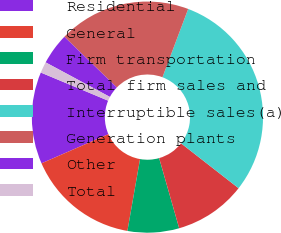Convert chart. <chart><loc_0><loc_0><loc_500><loc_500><pie_chart><fcel>Residential<fcel>General<fcel>Firm transportation<fcel>Total firm sales and<fcel>Interruptible sales(a)<fcel>Generation plants<fcel>Other<fcel>Total<nl><fcel>12.85%<fcel>15.68%<fcel>7.2%<fcel>10.03%<fcel>29.81%<fcel>18.5%<fcel>4.38%<fcel>1.55%<nl></chart> 